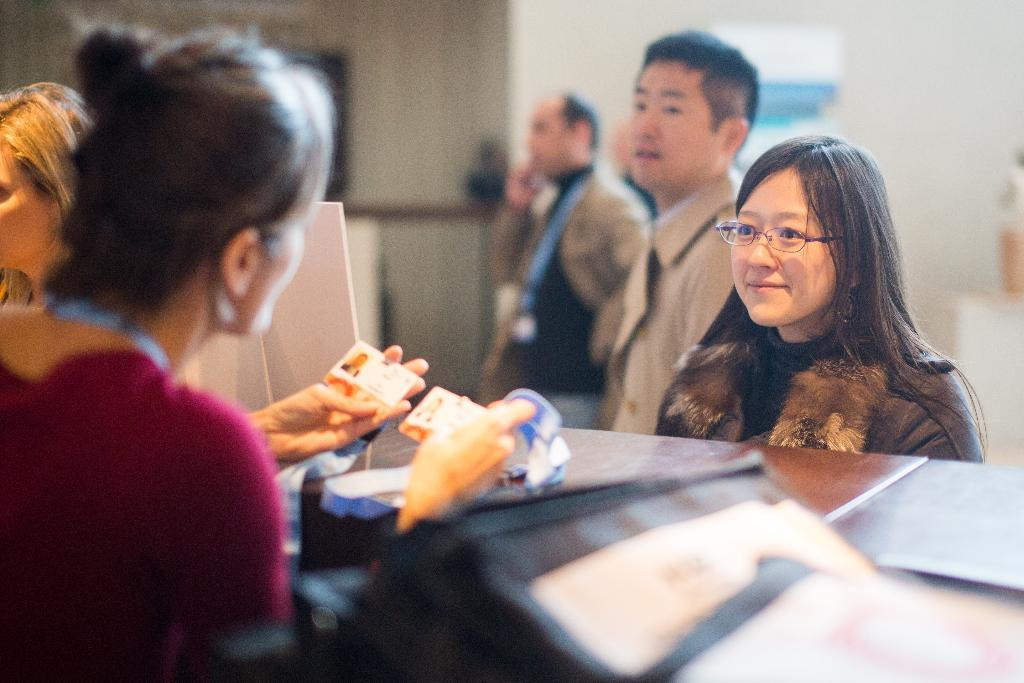How many people are in the image? There are persons in the image. What is one of the persons holding in the image? A person is holding cards with her hands. What type of furniture can be seen in the image? There are tables in the image. What is visible in the background of the image? There is a wall in the background of the image. How many sisters does the person holding cards have in the image? There is no information about sisters or family relationships in the image. 